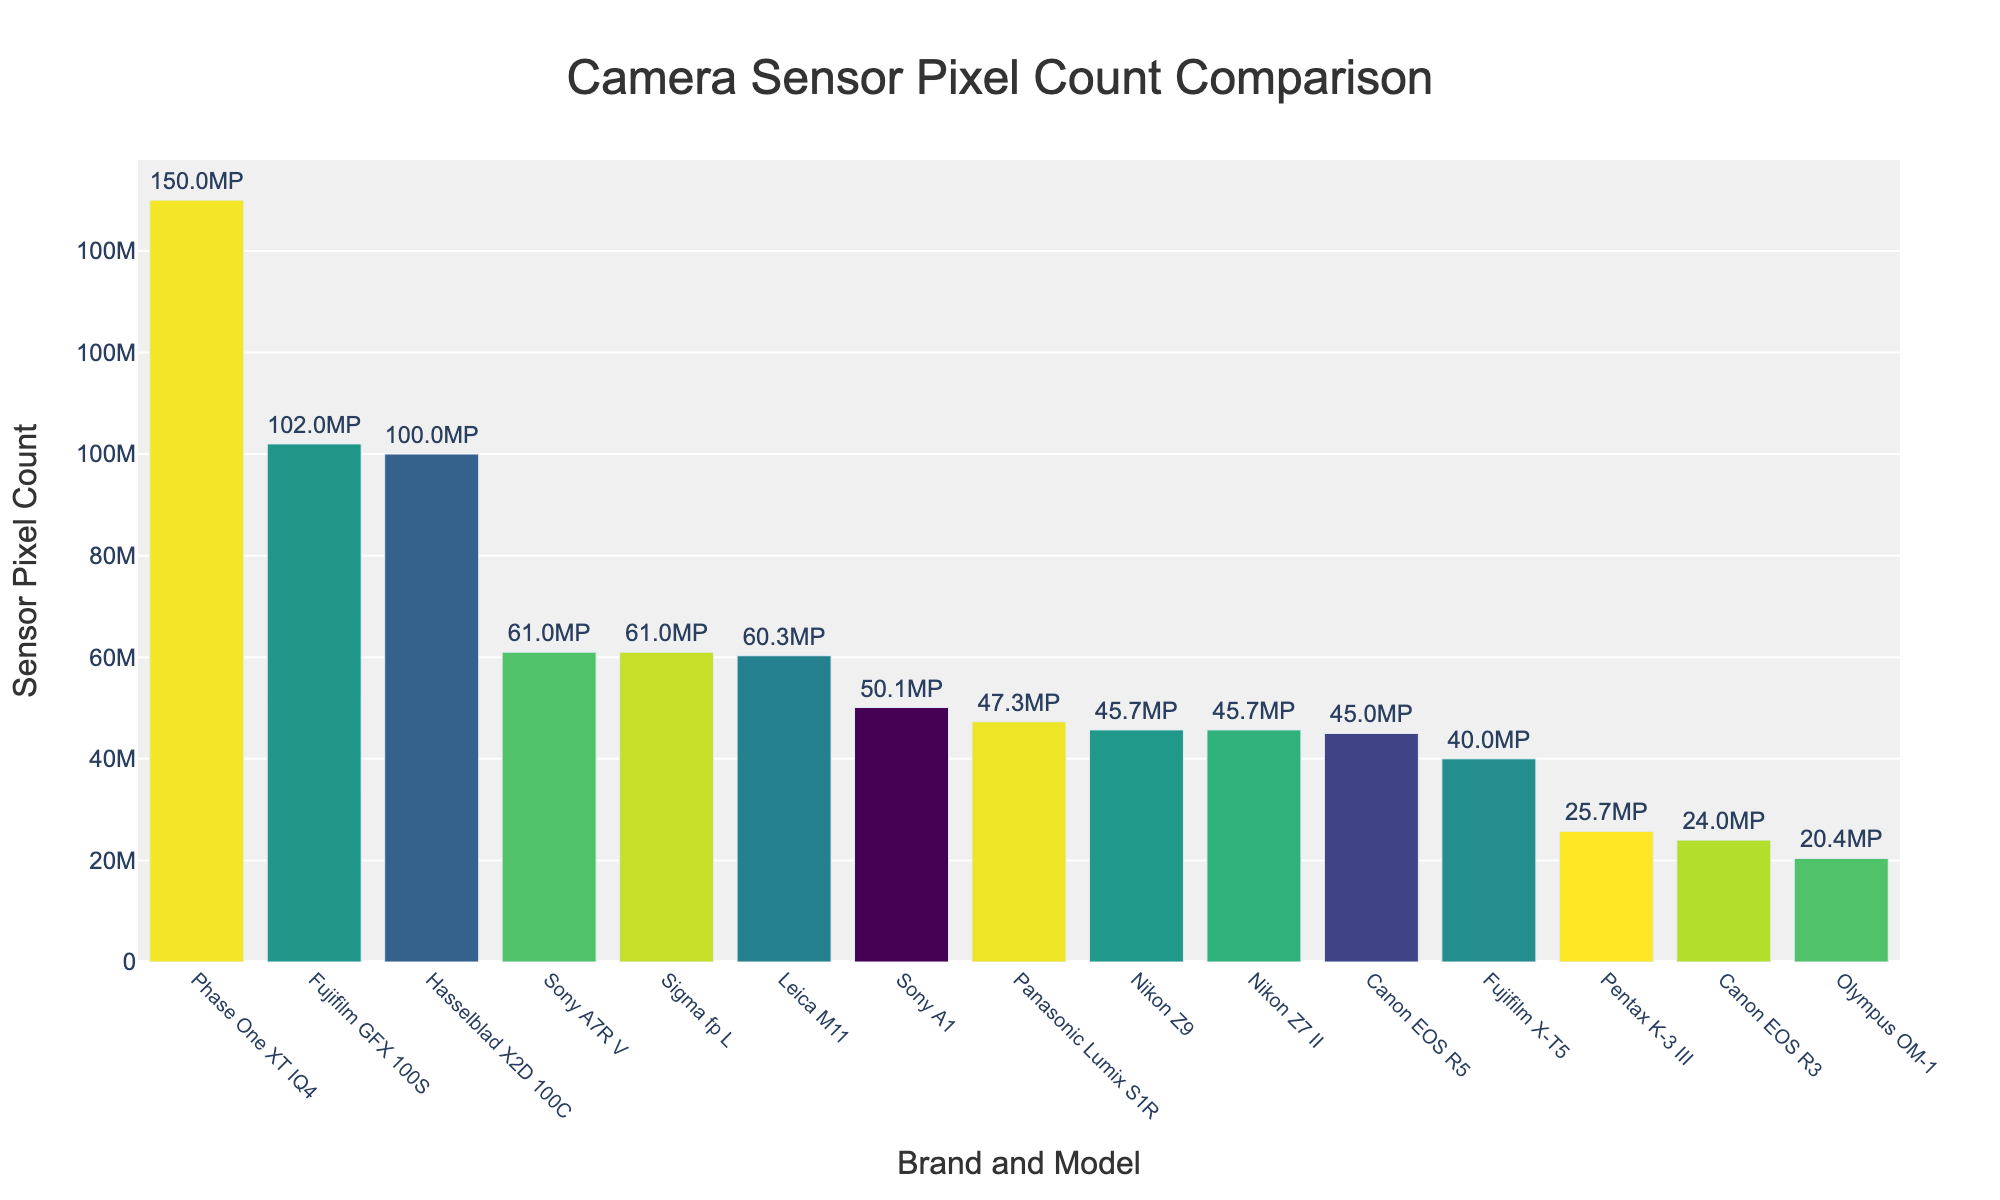What is the title of the plot? The title is located at the top center of the plot and is in a large font size.
Answer: Camera Sensor Pixel Count Comparison Which brand and model has the highest sensor pixel count? Scan the vertical bars and identify the tallest one, then refer to the corresponding label on the x-axis.
Answer: Phase One XT IQ4 What is the sensor pixel count of the Canon EOS R5? Locate "Canon EOS R5" on the x-axis and read the sensor pixel count value from the bar's label.
Answer: 45,000,000 How do the sensor pixel counts of the Nikon Z9 and the Sony A7R V compare? Find both models on the x-axis and compare the heights of their bars as well as the labels.
Answer: Sony A7R V has a higher sensor pixel count than Nikon Z9 What is the sensor pixel count of the lowest ranked model? Identify the shortest bar on the plot and read the label for sensor pixel count from the figure.
Answer: 20,400,000 What is the total sensor pixel count for all FujiFilm models shown? Locate both FujiFilm models (X-T5 and GFX 100S), then sum their sensor pixel counts.
Answer: 40,000,000 + 102,000,000 = 142,000,000 Which models have a sensor pixel count above 50 million? Identify and list the models with bars exceeding the 50 million mark on the y-axis.
Answer: Sony A7R V, Leica M11, Hasselblad X2D 100C, Phase One XT IQ4, Sony A1, Sigma fp L What is the average sensor pixel count among all the models listed? Add all the sensor pixel counts and divide by the number of models to find the mean.
Answer: (45000000+45700000+61000000+40000000+47300000+60300000+100000000+150000000+50100000+24000000+45700000+102000000+20400000+25730000+61000000)/15 = 54,913,133.33 Which brand has the most models listed? Count the number of occurrences for each brand in the list and identify the maximum.
Answer: Sony (2 models: A7R V, A1) 